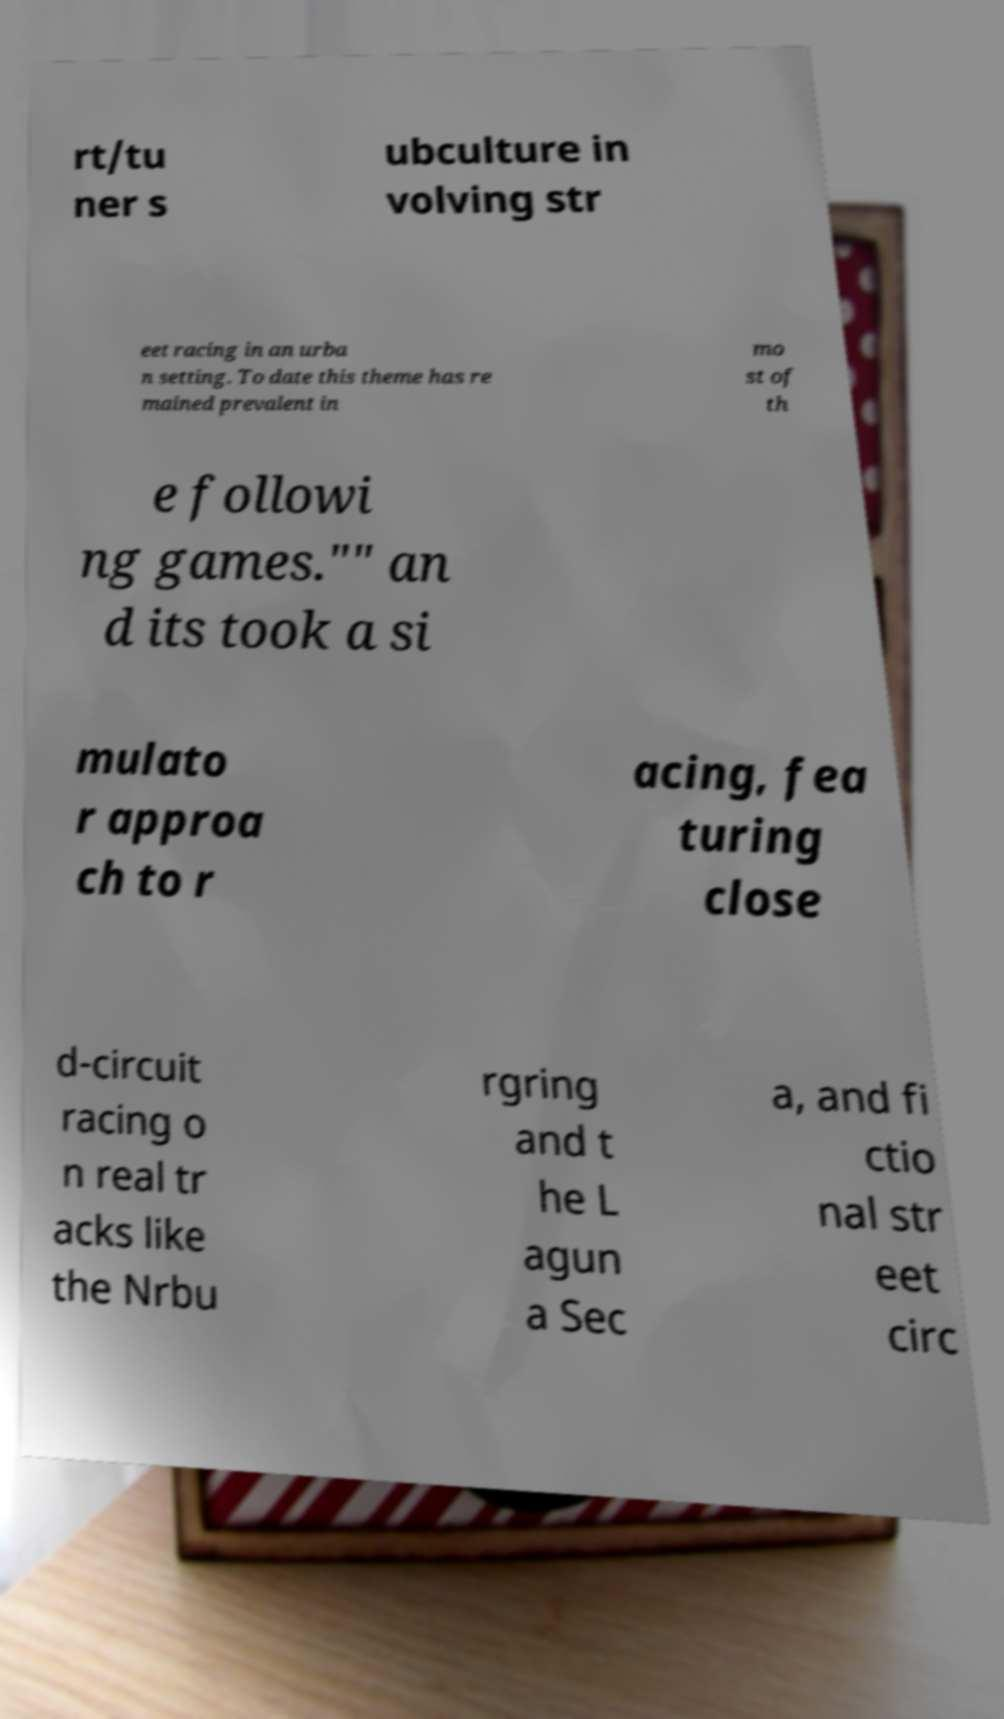Could you extract and type out the text from this image? rt/tu ner s ubculture in volving str eet racing in an urba n setting. To date this theme has re mained prevalent in mo st of th e followi ng games."" an d its took a si mulato r approa ch to r acing, fea turing close d-circuit racing o n real tr acks like the Nrbu rgring and t he L agun a Sec a, and fi ctio nal str eet circ 